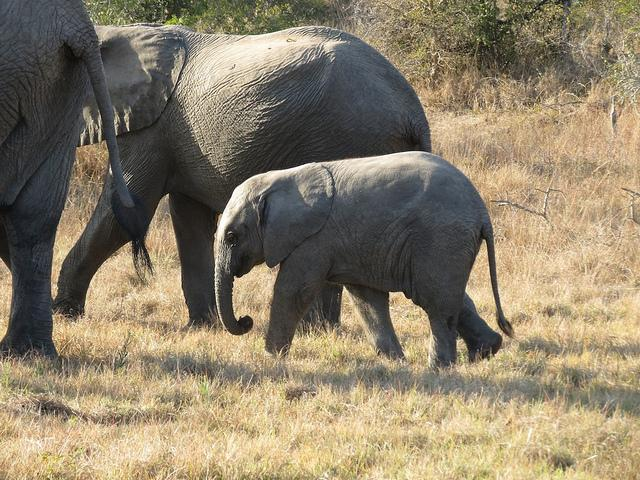How many little elephants are following behind the big elephant to the left? Please explain your reasoning. two. There is one small elephant lagging behind two bigger elephants on a field. 